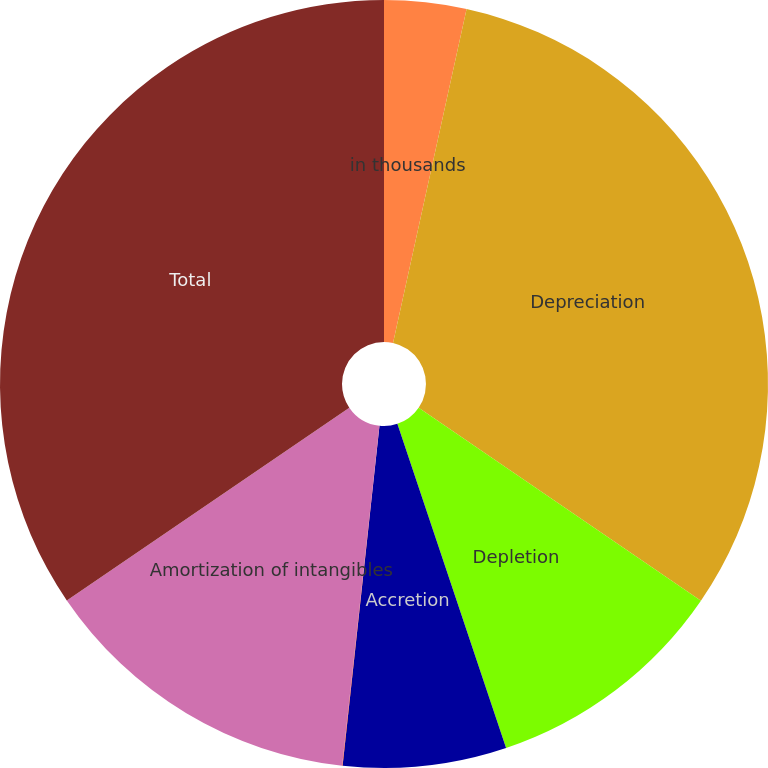Convert chart to OTSL. <chart><loc_0><loc_0><loc_500><loc_500><pie_chart><fcel>in thousands<fcel>Depreciation<fcel>Depletion<fcel>Accretion<fcel>Amortization of leaseholds<fcel>Amortization of intangibles<fcel>Total<nl><fcel>3.45%<fcel>31.1%<fcel>10.3%<fcel>6.87%<fcel>0.02%<fcel>13.73%<fcel>34.53%<nl></chart> 